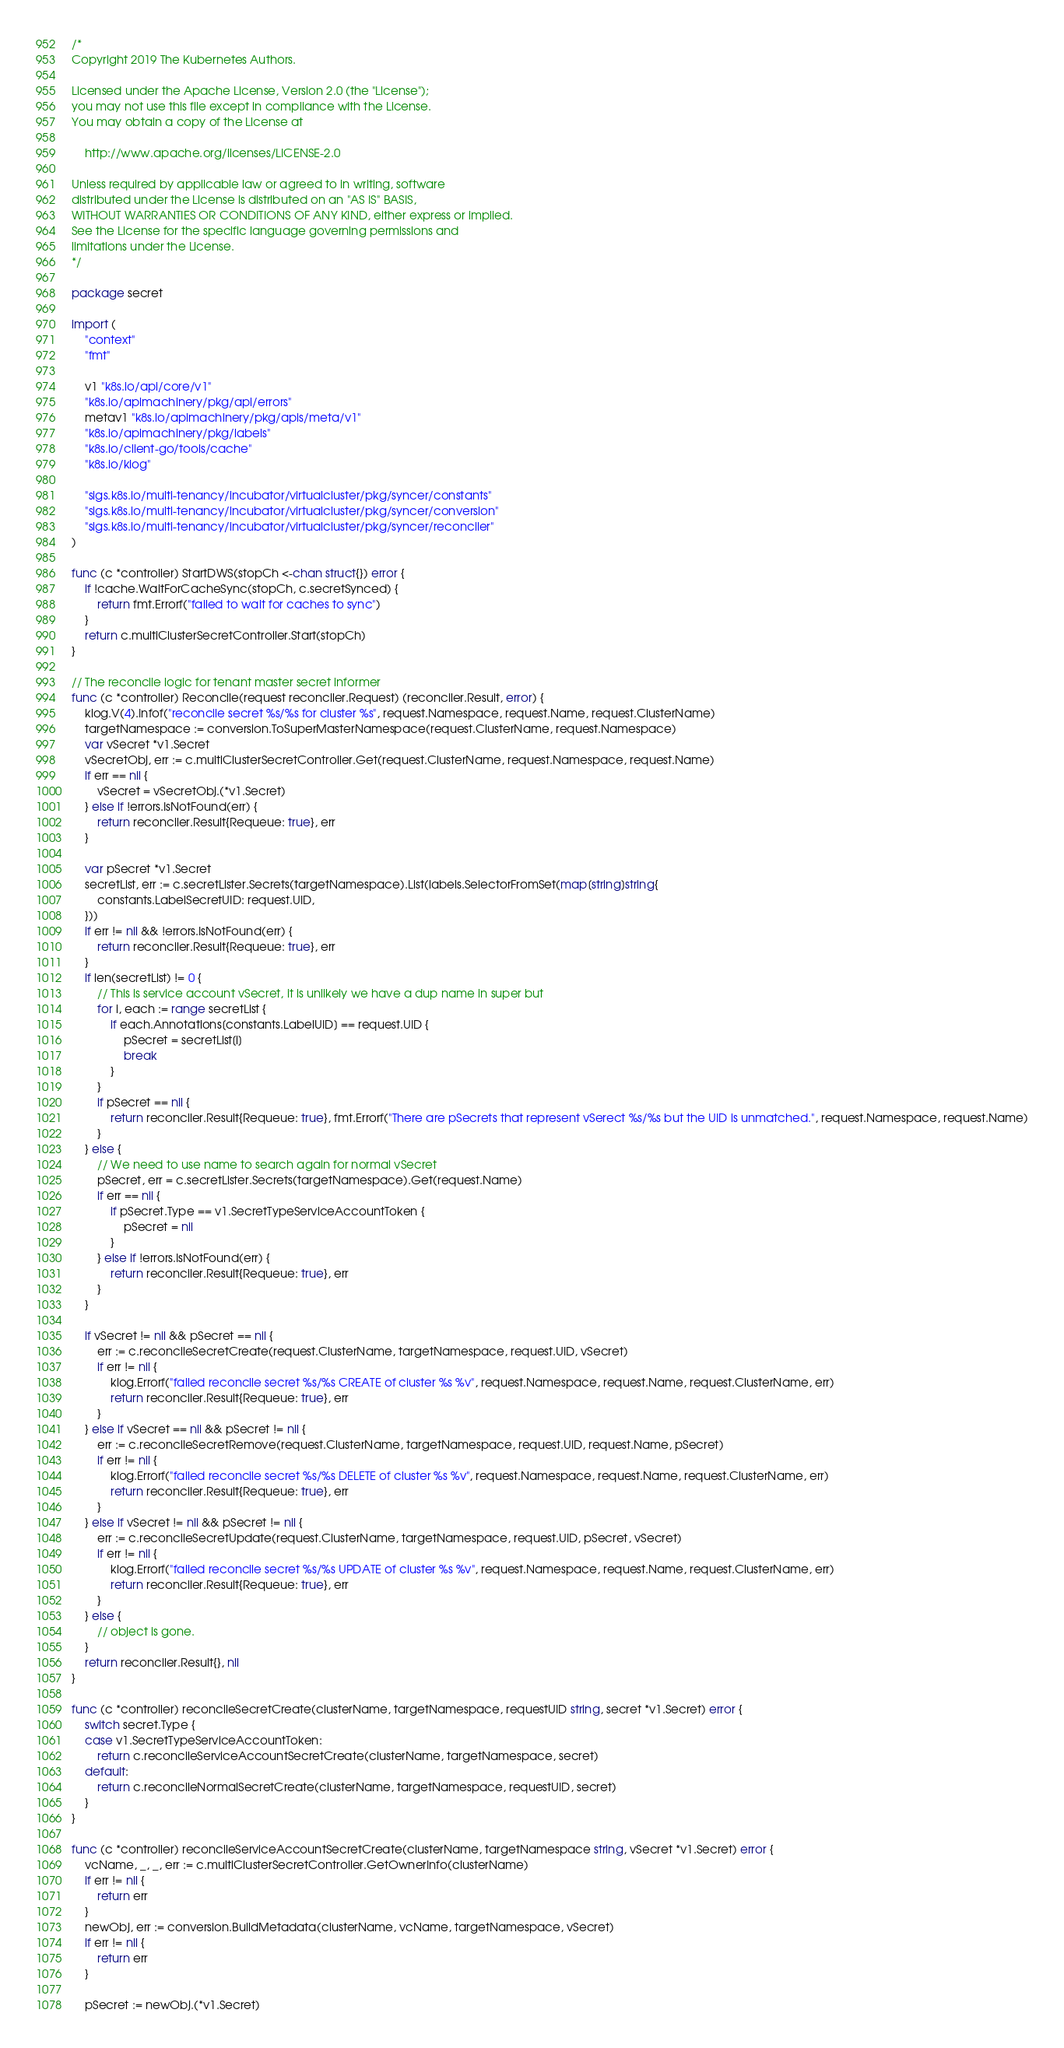Convert code to text. <code><loc_0><loc_0><loc_500><loc_500><_Go_>/*
Copyright 2019 The Kubernetes Authors.

Licensed under the Apache License, Version 2.0 (the "License");
you may not use this file except in compliance with the License.
You may obtain a copy of the License at

    http://www.apache.org/licenses/LICENSE-2.0

Unless required by applicable law or agreed to in writing, software
distributed under the License is distributed on an "AS IS" BASIS,
WITHOUT WARRANTIES OR CONDITIONS OF ANY KIND, either express or implied.
See the License for the specific language governing permissions and
limitations under the License.
*/

package secret

import (
	"context"
	"fmt"

	v1 "k8s.io/api/core/v1"
	"k8s.io/apimachinery/pkg/api/errors"
	metav1 "k8s.io/apimachinery/pkg/apis/meta/v1"
	"k8s.io/apimachinery/pkg/labels"
	"k8s.io/client-go/tools/cache"
	"k8s.io/klog"

	"sigs.k8s.io/multi-tenancy/incubator/virtualcluster/pkg/syncer/constants"
	"sigs.k8s.io/multi-tenancy/incubator/virtualcluster/pkg/syncer/conversion"
	"sigs.k8s.io/multi-tenancy/incubator/virtualcluster/pkg/syncer/reconciler"
)

func (c *controller) StartDWS(stopCh <-chan struct{}) error {
	if !cache.WaitForCacheSync(stopCh, c.secretSynced) {
		return fmt.Errorf("failed to wait for caches to sync")
	}
	return c.multiClusterSecretController.Start(stopCh)
}

// The reconcile logic for tenant master secret informer
func (c *controller) Reconcile(request reconciler.Request) (reconciler.Result, error) {
	klog.V(4).Infof("reconcile secret %s/%s for cluster %s", request.Namespace, request.Name, request.ClusterName)
	targetNamespace := conversion.ToSuperMasterNamespace(request.ClusterName, request.Namespace)
	var vSecret *v1.Secret
	vSecretObj, err := c.multiClusterSecretController.Get(request.ClusterName, request.Namespace, request.Name)
	if err == nil {
		vSecret = vSecretObj.(*v1.Secret)
	} else if !errors.IsNotFound(err) {
		return reconciler.Result{Requeue: true}, err
	}

	var pSecret *v1.Secret
	secretList, err := c.secretLister.Secrets(targetNamespace).List(labels.SelectorFromSet(map[string]string{
		constants.LabelSecretUID: request.UID,
	}))
	if err != nil && !errors.IsNotFound(err) {
		return reconciler.Result{Requeue: true}, err
	}
	if len(secretList) != 0 {
		// This is service account vSecret, it is unlikely we have a dup name in super but
		for i, each := range secretList {
			if each.Annotations[constants.LabelUID] == request.UID {
				pSecret = secretList[i]
				break
			}
		}
		if pSecret == nil {
			return reconciler.Result{Requeue: true}, fmt.Errorf("There are pSecrets that represent vSerect %s/%s but the UID is unmatched.", request.Namespace, request.Name)
		}
	} else {
		// We need to use name to search again for normal vSecret
		pSecret, err = c.secretLister.Secrets(targetNamespace).Get(request.Name)
		if err == nil {
			if pSecret.Type == v1.SecretTypeServiceAccountToken {
				pSecret = nil
			}
		} else if !errors.IsNotFound(err) {
			return reconciler.Result{Requeue: true}, err
		}
	}

	if vSecret != nil && pSecret == nil {
		err := c.reconcileSecretCreate(request.ClusterName, targetNamespace, request.UID, vSecret)
		if err != nil {
			klog.Errorf("failed reconcile secret %s/%s CREATE of cluster %s %v", request.Namespace, request.Name, request.ClusterName, err)
			return reconciler.Result{Requeue: true}, err
		}
	} else if vSecret == nil && pSecret != nil {
		err := c.reconcileSecretRemove(request.ClusterName, targetNamespace, request.UID, request.Name, pSecret)
		if err != nil {
			klog.Errorf("failed reconcile secret %s/%s DELETE of cluster %s %v", request.Namespace, request.Name, request.ClusterName, err)
			return reconciler.Result{Requeue: true}, err
		}
	} else if vSecret != nil && pSecret != nil {
		err := c.reconcileSecretUpdate(request.ClusterName, targetNamespace, request.UID, pSecret, vSecret)
		if err != nil {
			klog.Errorf("failed reconcile secret %s/%s UPDATE of cluster %s %v", request.Namespace, request.Name, request.ClusterName, err)
			return reconciler.Result{Requeue: true}, err
		}
	} else {
		// object is gone.
	}
	return reconciler.Result{}, nil
}

func (c *controller) reconcileSecretCreate(clusterName, targetNamespace, requestUID string, secret *v1.Secret) error {
	switch secret.Type {
	case v1.SecretTypeServiceAccountToken:
		return c.reconcileServiceAccountSecretCreate(clusterName, targetNamespace, secret)
	default:
		return c.reconcileNormalSecretCreate(clusterName, targetNamespace, requestUID, secret)
	}
}

func (c *controller) reconcileServiceAccountSecretCreate(clusterName, targetNamespace string, vSecret *v1.Secret) error {
	vcName, _, _, err := c.multiClusterSecretController.GetOwnerInfo(clusterName)
	if err != nil {
		return err
	}
	newObj, err := conversion.BuildMetadata(clusterName, vcName, targetNamespace, vSecret)
	if err != nil {
		return err
	}

	pSecret := newObj.(*v1.Secret)</code> 